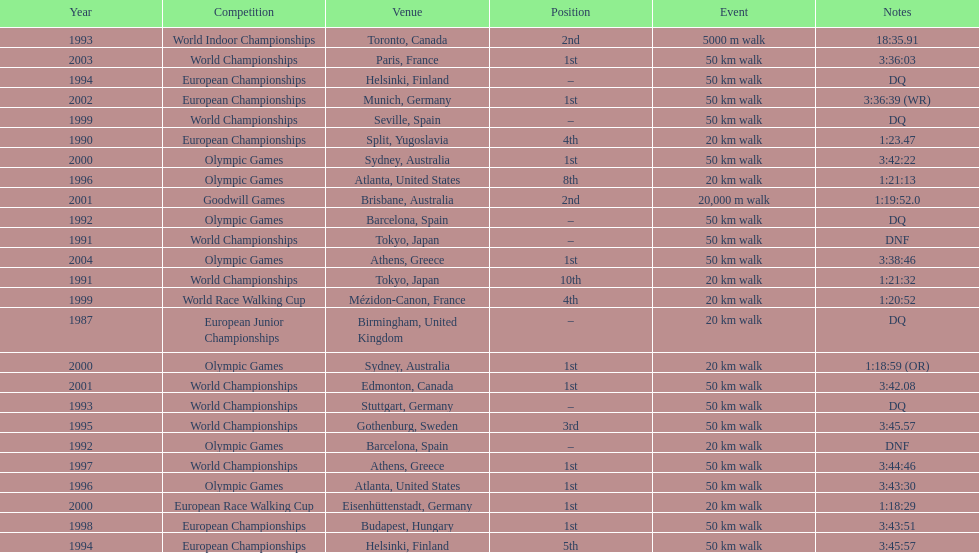Which venue is listed the most? Athens, Greece. 